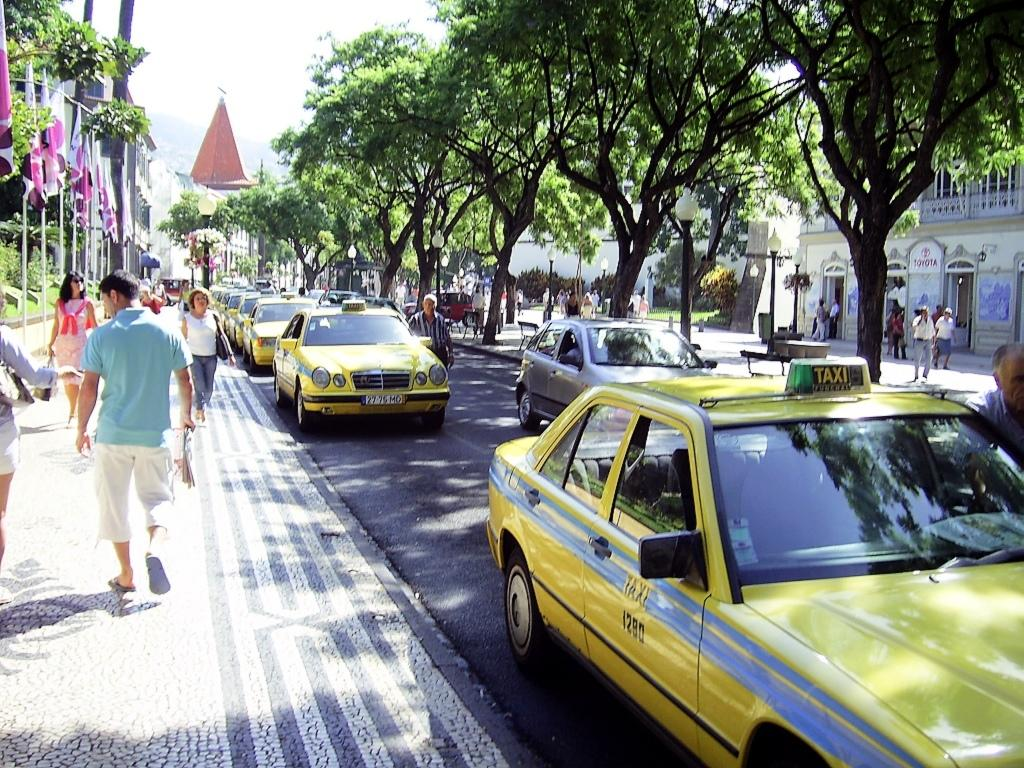<image>
Give a short and clear explanation of the subsequent image. a yellow taxi that is on the side of the road 